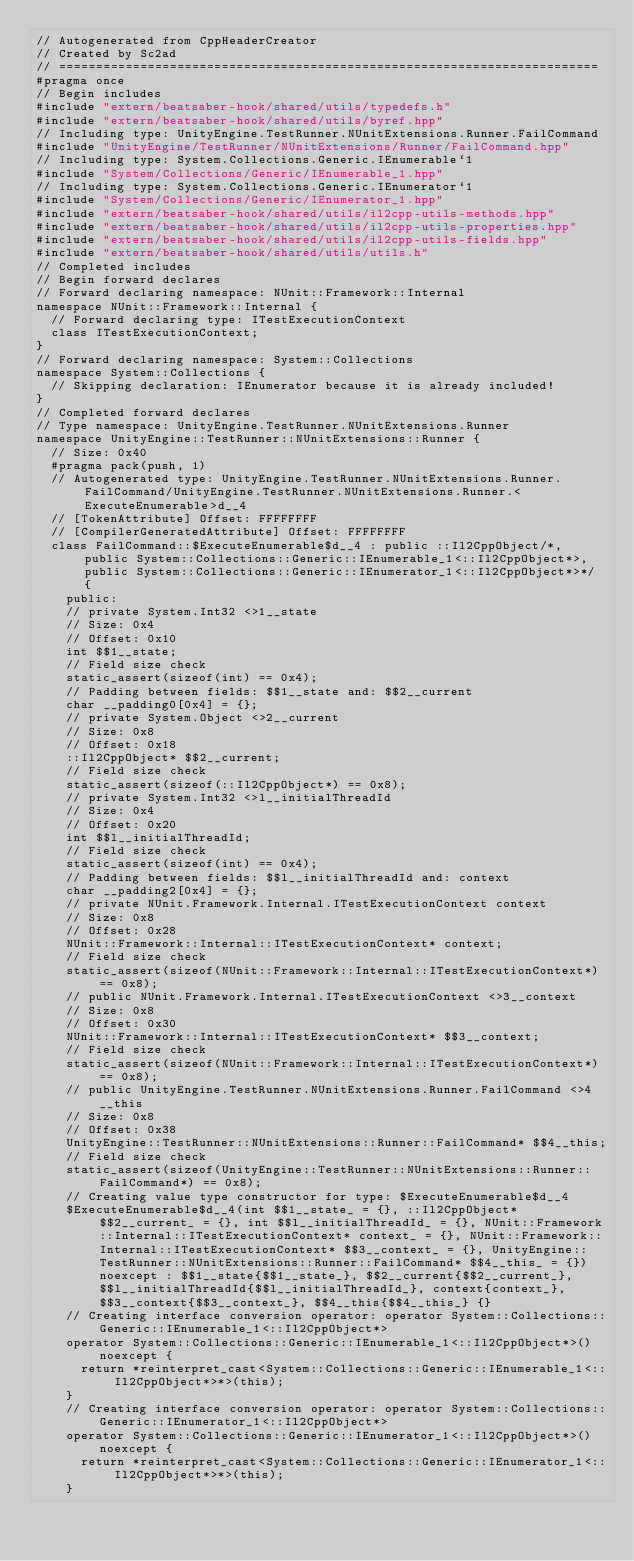<code> <loc_0><loc_0><loc_500><loc_500><_C++_>// Autogenerated from CppHeaderCreator
// Created by Sc2ad
// =========================================================================
#pragma once
// Begin includes
#include "extern/beatsaber-hook/shared/utils/typedefs.h"
#include "extern/beatsaber-hook/shared/utils/byref.hpp"
// Including type: UnityEngine.TestRunner.NUnitExtensions.Runner.FailCommand
#include "UnityEngine/TestRunner/NUnitExtensions/Runner/FailCommand.hpp"
// Including type: System.Collections.Generic.IEnumerable`1
#include "System/Collections/Generic/IEnumerable_1.hpp"
// Including type: System.Collections.Generic.IEnumerator`1
#include "System/Collections/Generic/IEnumerator_1.hpp"
#include "extern/beatsaber-hook/shared/utils/il2cpp-utils-methods.hpp"
#include "extern/beatsaber-hook/shared/utils/il2cpp-utils-properties.hpp"
#include "extern/beatsaber-hook/shared/utils/il2cpp-utils-fields.hpp"
#include "extern/beatsaber-hook/shared/utils/utils.h"
// Completed includes
// Begin forward declares
// Forward declaring namespace: NUnit::Framework::Internal
namespace NUnit::Framework::Internal {
  // Forward declaring type: ITestExecutionContext
  class ITestExecutionContext;
}
// Forward declaring namespace: System::Collections
namespace System::Collections {
  // Skipping declaration: IEnumerator because it is already included!
}
// Completed forward declares
// Type namespace: UnityEngine.TestRunner.NUnitExtensions.Runner
namespace UnityEngine::TestRunner::NUnitExtensions::Runner {
  // Size: 0x40
  #pragma pack(push, 1)
  // Autogenerated type: UnityEngine.TestRunner.NUnitExtensions.Runner.FailCommand/UnityEngine.TestRunner.NUnitExtensions.Runner.<ExecuteEnumerable>d__4
  // [TokenAttribute] Offset: FFFFFFFF
  // [CompilerGeneratedAttribute] Offset: FFFFFFFF
  class FailCommand::$ExecuteEnumerable$d__4 : public ::Il2CppObject/*, public System::Collections::Generic::IEnumerable_1<::Il2CppObject*>, public System::Collections::Generic::IEnumerator_1<::Il2CppObject*>*/ {
    public:
    // private System.Int32 <>1__state
    // Size: 0x4
    // Offset: 0x10
    int $$1__state;
    // Field size check
    static_assert(sizeof(int) == 0x4);
    // Padding between fields: $$1__state and: $$2__current
    char __padding0[0x4] = {};
    // private System.Object <>2__current
    // Size: 0x8
    // Offset: 0x18
    ::Il2CppObject* $$2__current;
    // Field size check
    static_assert(sizeof(::Il2CppObject*) == 0x8);
    // private System.Int32 <>l__initialThreadId
    // Size: 0x4
    // Offset: 0x20
    int $$l__initialThreadId;
    // Field size check
    static_assert(sizeof(int) == 0x4);
    // Padding between fields: $$l__initialThreadId and: context
    char __padding2[0x4] = {};
    // private NUnit.Framework.Internal.ITestExecutionContext context
    // Size: 0x8
    // Offset: 0x28
    NUnit::Framework::Internal::ITestExecutionContext* context;
    // Field size check
    static_assert(sizeof(NUnit::Framework::Internal::ITestExecutionContext*) == 0x8);
    // public NUnit.Framework.Internal.ITestExecutionContext <>3__context
    // Size: 0x8
    // Offset: 0x30
    NUnit::Framework::Internal::ITestExecutionContext* $$3__context;
    // Field size check
    static_assert(sizeof(NUnit::Framework::Internal::ITestExecutionContext*) == 0x8);
    // public UnityEngine.TestRunner.NUnitExtensions.Runner.FailCommand <>4__this
    // Size: 0x8
    // Offset: 0x38
    UnityEngine::TestRunner::NUnitExtensions::Runner::FailCommand* $$4__this;
    // Field size check
    static_assert(sizeof(UnityEngine::TestRunner::NUnitExtensions::Runner::FailCommand*) == 0x8);
    // Creating value type constructor for type: $ExecuteEnumerable$d__4
    $ExecuteEnumerable$d__4(int $$1__state_ = {}, ::Il2CppObject* $$2__current_ = {}, int $$l__initialThreadId_ = {}, NUnit::Framework::Internal::ITestExecutionContext* context_ = {}, NUnit::Framework::Internal::ITestExecutionContext* $$3__context_ = {}, UnityEngine::TestRunner::NUnitExtensions::Runner::FailCommand* $$4__this_ = {}) noexcept : $$1__state{$$1__state_}, $$2__current{$$2__current_}, $$l__initialThreadId{$$l__initialThreadId_}, context{context_}, $$3__context{$$3__context_}, $$4__this{$$4__this_} {}
    // Creating interface conversion operator: operator System::Collections::Generic::IEnumerable_1<::Il2CppObject*>
    operator System::Collections::Generic::IEnumerable_1<::Il2CppObject*>() noexcept {
      return *reinterpret_cast<System::Collections::Generic::IEnumerable_1<::Il2CppObject*>*>(this);
    }
    // Creating interface conversion operator: operator System::Collections::Generic::IEnumerator_1<::Il2CppObject*>
    operator System::Collections::Generic::IEnumerator_1<::Il2CppObject*>() noexcept {
      return *reinterpret_cast<System::Collections::Generic::IEnumerator_1<::Il2CppObject*>*>(this);
    }</code> 